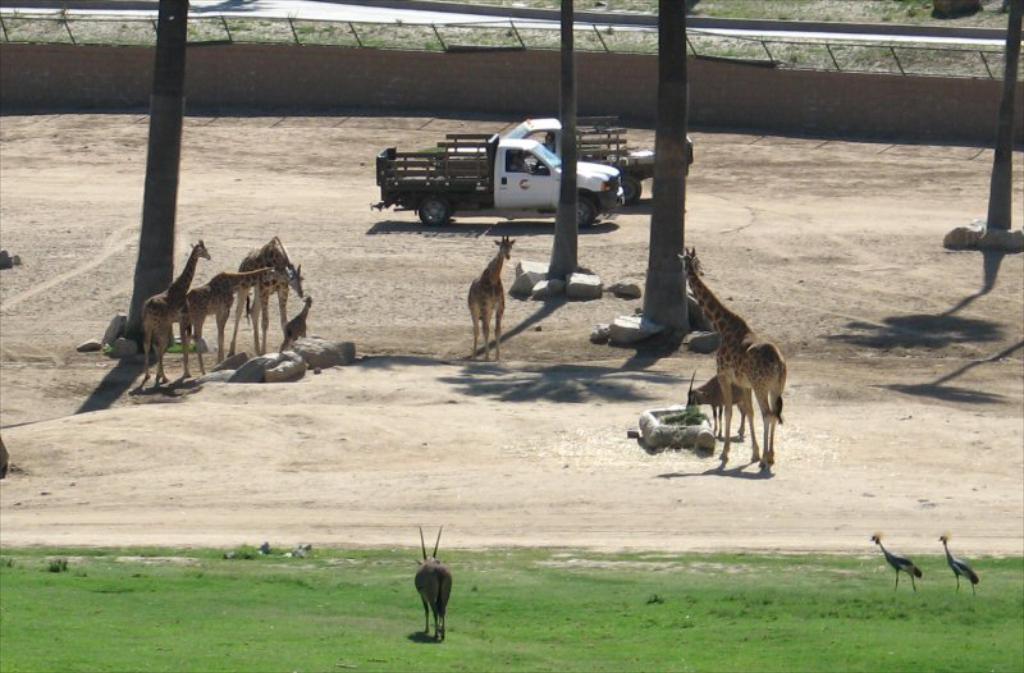Can you describe this image briefly? In the center of the image we can see animals. On the right there are birds. At the bottom there is grass. In the background there are trees, vehicles and a wall. 